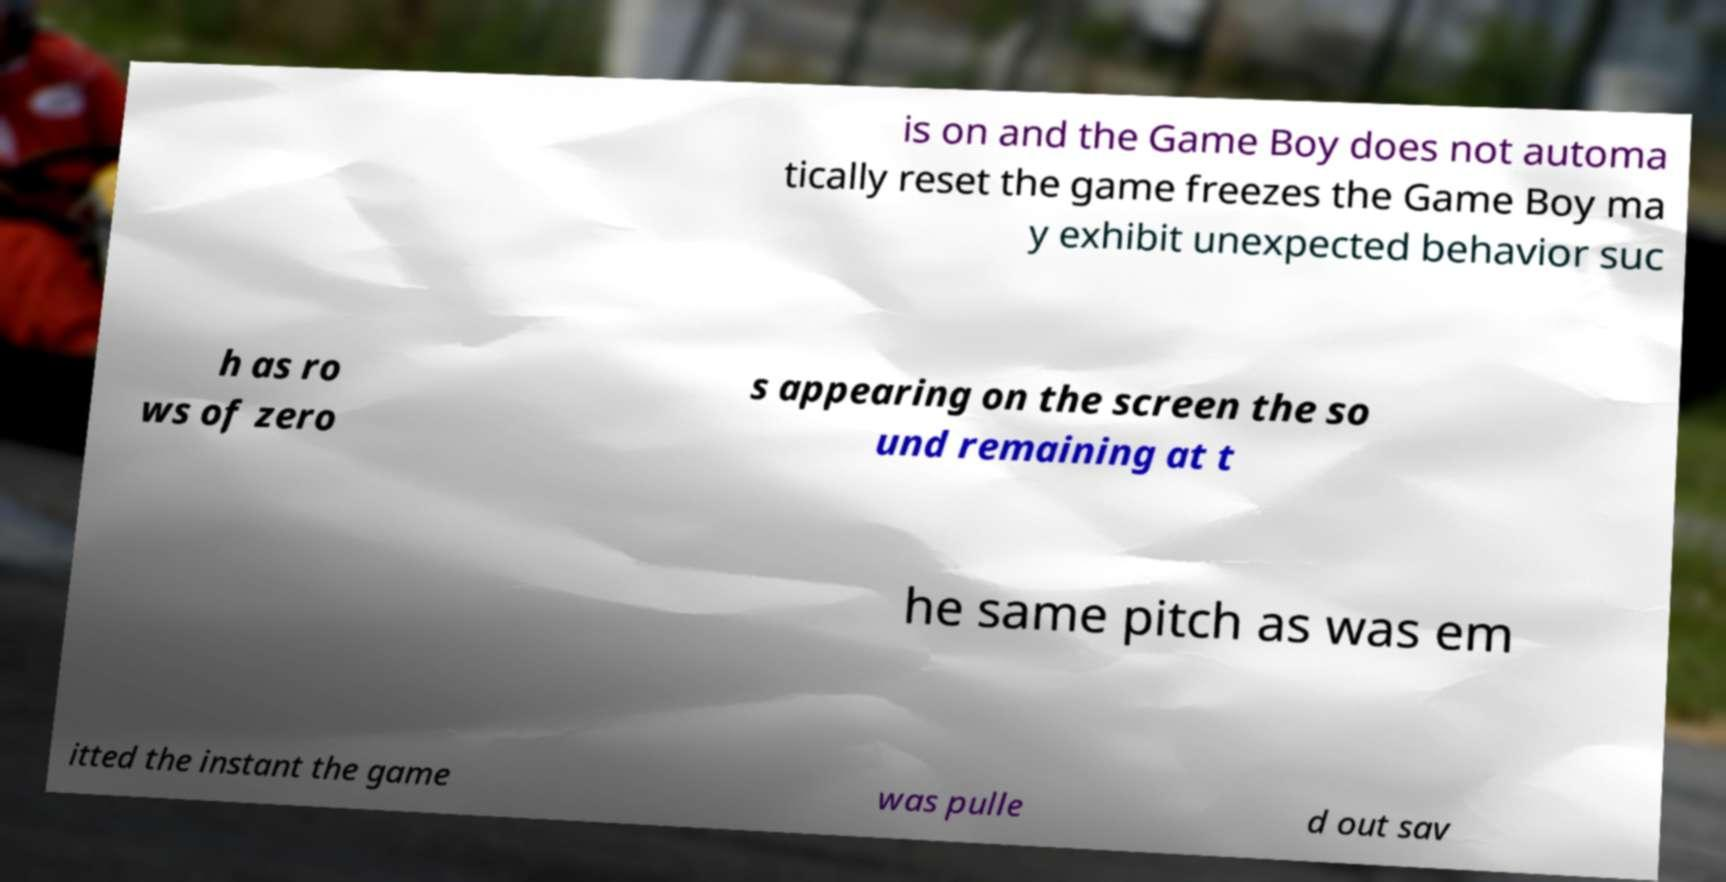Could you assist in decoding the text presented in this image and type it out clearly? is on and the Game Boy does not automa tically reset the game freezes the Game Boy ma y exhibit unexpected behavior suc h as ro ws of zero s appearing on the screen the so und remaining at t he same pitch as was em itted the instant the game was pulle d out sav 